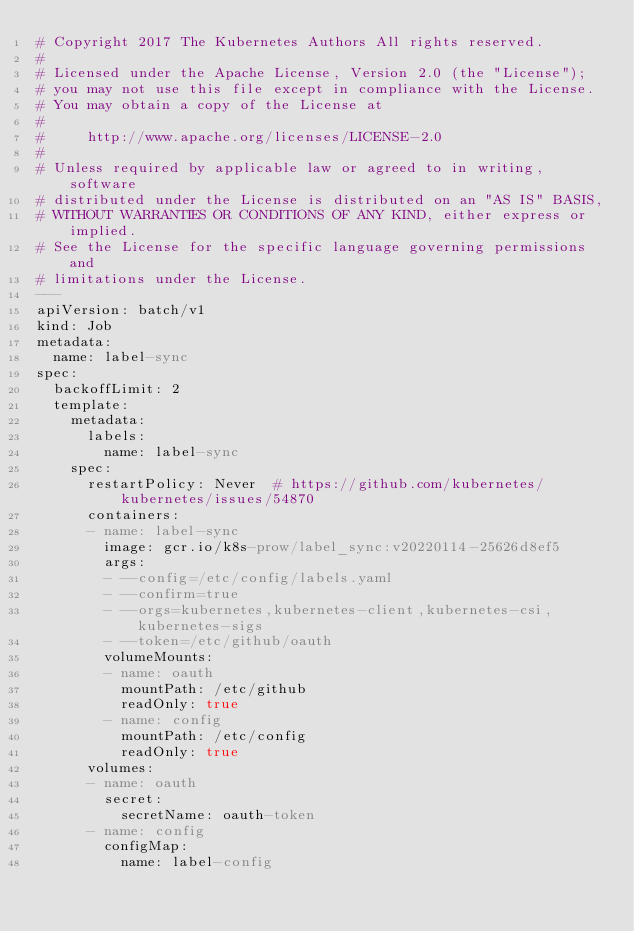Convert code to text. <code><loc_0><loc_0><loc_500><loc_500><_YAML_># Copyright 2017 The Kubernetes Authors All rights reserved.
#
# Licensed under the Apache License, Version 2.0 (the "License");
# you may not use this file except in compliance with the License.
# You may obtain a copy of the License at
#
#     http://www.apache.org/licenses/LICENSE-2.0
#
# Unless required by applicable law or agreed to in writing, software
# distributed under the License is distributed on an "AS IS" BASIS,
# WITHOUT WARRANTIES OR CONDITIONS OF ANY KIND, either express or implied.
# See the License for the specific language governing permissions and
# limitations under the License.
---
apiVersion: batch/v1
kind: Job
metadata:
  name: label-sync
spec:
  backoffLimit: 2
  template:
    metadata:
      labels:
        name: label-sync
    spec:
      restartPolicy: Never  # https://github.com/kubernetes/kubernetes/issues/54870
      containers:
      - name: label-sync
        image: gcr.io/k8s-prow/label_sync:v20220114-25626d8ef5
        args:
        - --config=/etc/config/labels.yaml
        - --confirm=true
        - --orgs=kubernetes,kubernetes-client,kubernetes-csi,kubernetes-sigs
        - --token=/etc/github/oauth
        volumeMounts:
        - name: oauth
          mountPath: /etc/github
          readOnly: true
        - name: config
          mountPath: /etc/config
          readOnly: true
      volumes:
      - name: oauth
        secret:
          secretName: oauth-token
      - name: config
        configMap:
          name: label-config
</code> 